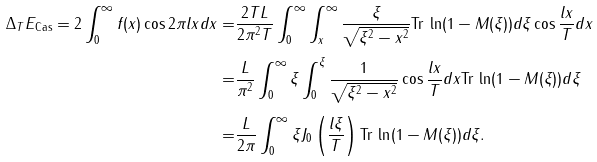Convert formula to latex. <formula><loc_0><loc_0><loc_500><loc_500>\Delta _ { T } E _ { \text {Cas} } = 2 \int _ { 0 } ^ { \infty } f ( x ) \cos 2 \pi l x d x = & \frac { 2 T L } { 2 \pi ^ { 2 } T } \int _ { 0 } ^ { \infty } \int _ { x } ^ { \infty } \frac { \xi } { \sqrt { \xi ^ { 2 } - x ^ { 2 } } } \text {Tr} \, \ln ( 1 - M ( \xi ) ) d \xi \cos \frac { l x } { T } d x \\ = & \frac { L } { \pi ^ { 2 } } \int _ { 0 } ^ { \infty } \xi \int _ { 0 } ^ { \xi } \frac { 1 } { \sqrt { \xi ^ { 2 } - x ^ { 2 } } } \cos \frac { l x } { T } d x \text {Tr} \, \ln ( 1 - M ( \xi ) ) d \xi \\ = & \frac { L } { 2 \pi } \int _ { 0 } ^ { \infty } \xi J _ { 0 } \left ( \frac { l \xi } { T } \right ) \text {Tr} \, \ln ( 1 - M ( \xi ) ) d \xi .</formula> 